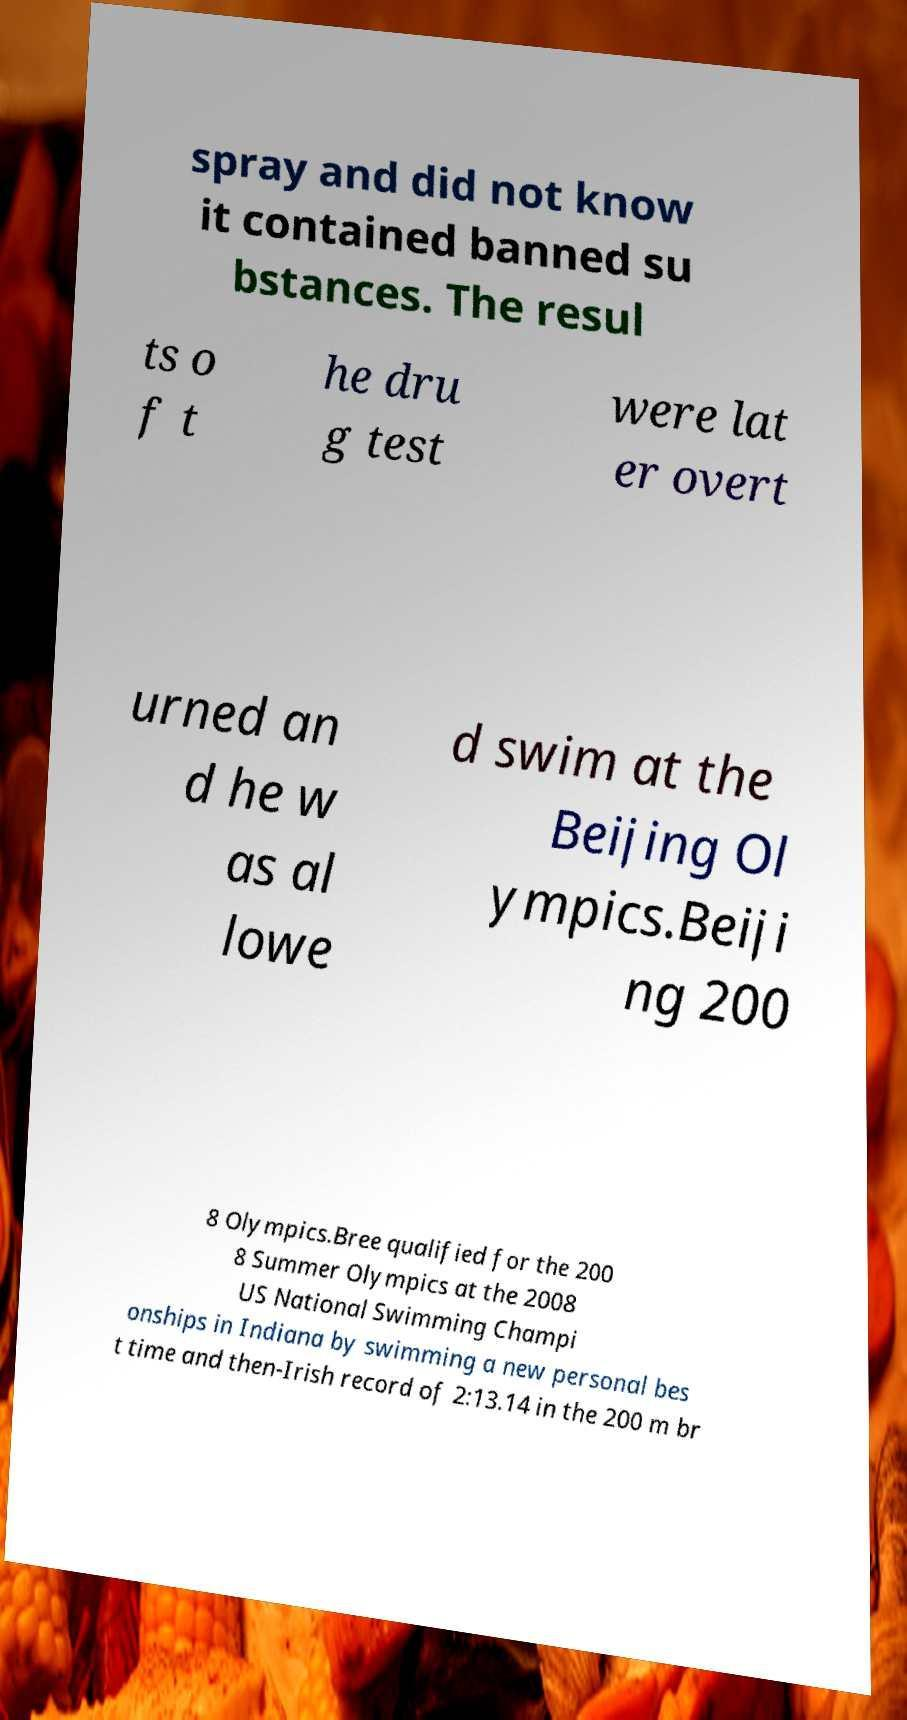Please read and relay the text visible in this image. What does it say? spray and did not know it contained banned su bstances. The resul ts o f t he dru g test were lat er overt urned an d he w as al lowe d swim at the Beijing Ol ympics.Beiji ng 200 8 Olympics.Bree qualified for the 200 8 Summer Olympics at the 2008 US National Swimming Champi onships in Indiana by swimming a new personal bes t time and then-Irish record of 2:13.14 in the 200 m br 